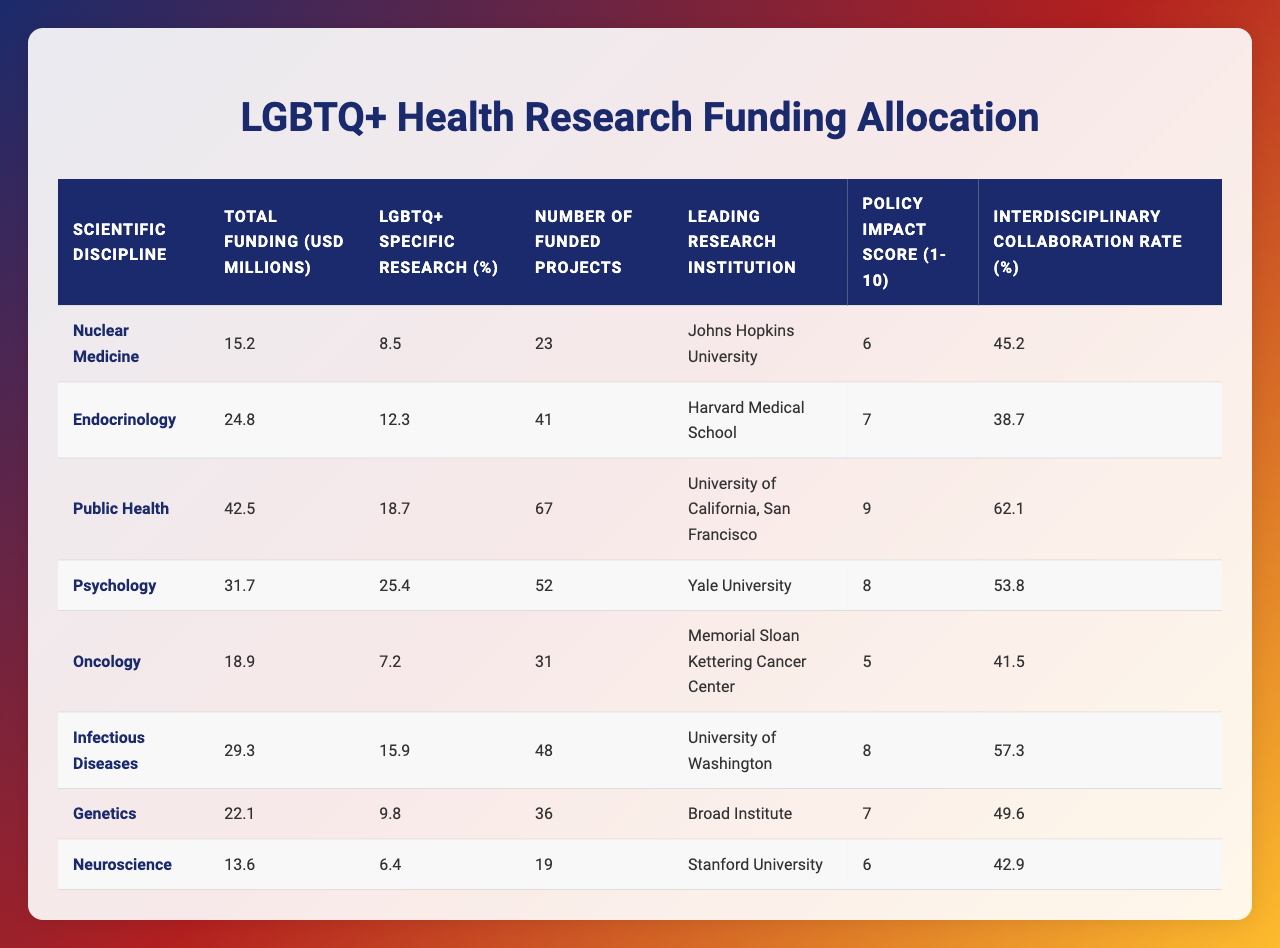What is the total funding allocated for LGBTQ+ health research in Endocrinology? The table shows the total funding for Endocrinology is 24.8 million USD.
Answer: 24.8 million USD Which scientific discipline has the highest percentage of LGBTQ+ specific research? The table indicates that Psychology has the highest percentage of LGBTQ+ specific research at 25.4%.
Answer: Psychology How many funded projects are there in the field of Infectious Diseases? According to the table, there are 48 funded projects in Infectious Diseases.
Answer: 48 What is the policy impact score for the scientific discipline with the least total funding? The discipline with the least total funding is Neuroscience with 13.6 million USD and has a policy impact score of 6.
Answer: 6 Which leading research institution is associated with the largest number of funded projects? The University of California, San Francisco is associated with the largest number of funded projects, which is 67.
Answer: University of California, San Francisco Calculate the average total funding for all the disciplines listed in the table. The total funding amounts to 24.2 million USD distributed amongst 8 disciplines. Thus, the average funding is calculated as (15.2 + 24.8 + 42.5 + 31.7 + 18.9 + 29.3 + 22.1 + 13.6) / 8 = 23.3 million USD.
Answer: 23.3 million USD Is the LGBTQ+ specific research percentage for Oncology greater than that for Nuclear Medicine? The table shows Oncology with 7.2% LGBTQ+ specific research and Nuclear Medicine with 8.5%, therefore the statement is false.
Answer: False Which scientific discipline shows the highest rate of interdisciplinary collaboration? Based on the table, Public Health displays the highest interdisciplinary collaboration rate at 62.1%.
Answer: Public Health Determine the total number of funded projects across all disciplines. Adding the number of funded projects: 23 + 41 + 67 + 52 + 31 + 48 + 36 + 19 = 317 projects.
Answer: 317 projects Is there a correlation between total funding and the number of funded projects? To determine this, we compare the total funding and number of funded projects. For instance, Endocrinology has a high number of projects (41) with a substantial funding of 24.8 million USD, suggesting a possible positive correlation. However, a thorough statistical analysis would be needed for a definitive answer.
Answer: Yes, but needs statistical analysis 